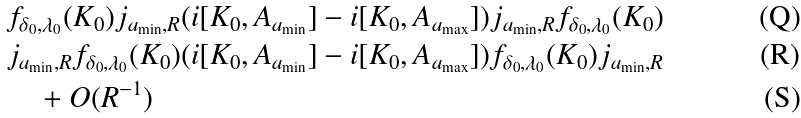Convert formula to latex. <formula><loc_0><loc_0><loc_500><loc_500>& f _ { \delta _ { 0 } , \lambda _ { 0 } } ( K _ { 0 } ) j _ { a _ { \min } , R } ( i [ K _ { 0 } , A _ { a _ { \min } } ] - i [ K _ { 0 } , A _ { a _ { \max } } ] ) j _ { a _ { \min } , R } f _ { \delta _ { 0 } , \lambda _ { 0 } } ( K _ { 0 } ) \\ & j _ { a _ { \min } , R } f _ { \delta _ { 0 } , \lambda _ { 0 } } ( K _ { 0 } ) ( i [ K _ { 0 } , A _ { a _ { \min } } ] - i [ K _ { 0 } , A _ { a _ { \max } } ] ) f _ { \delta _ { 0 } , \lambda _ { 0 } } ( K _ { 0 } ) j _ { a _ { \min } , R } \\ & \quad + O ( R ^ { - 1 } )</formula> 